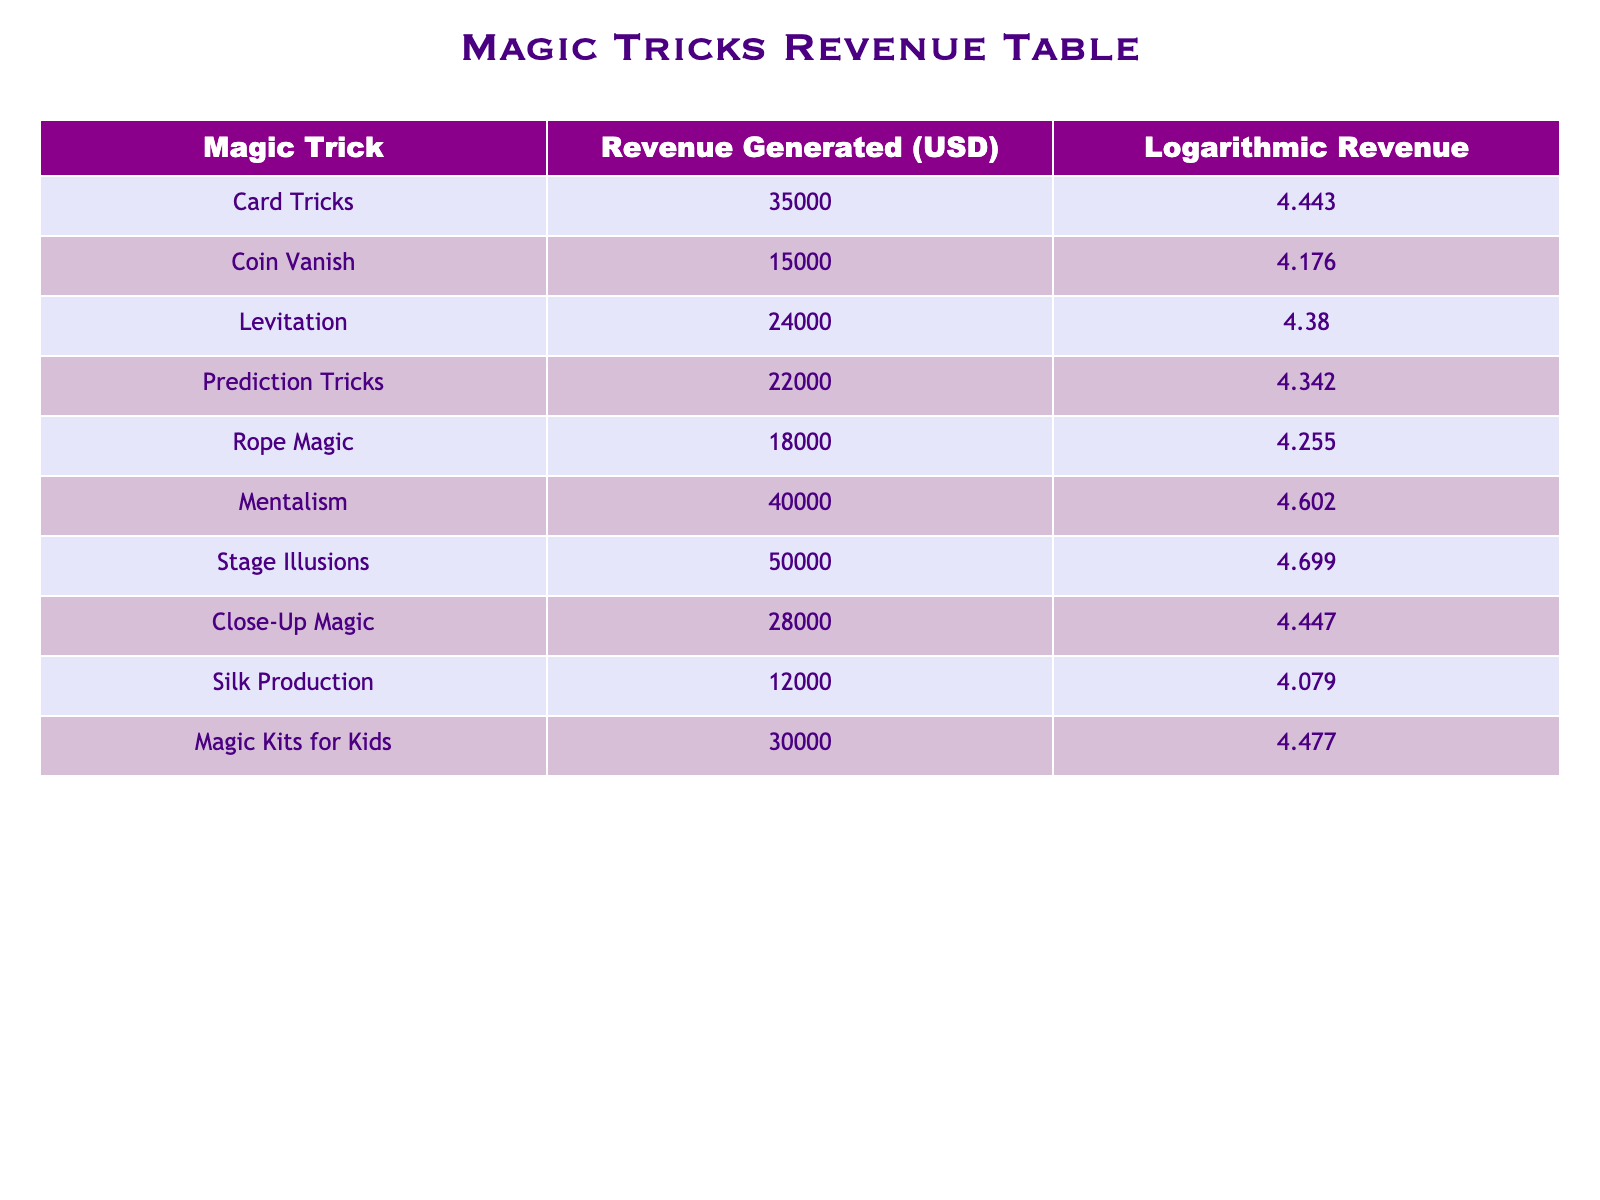What is the revenue generated from Stage Illusions? The table specifies the revenue values, and Stage Illusions are listed with a revenue of 50000 USD.
Answer: 50000 USD Which magic trick generated the lowest revenue? Reviewing the revenue figures, Silk Production shows the lowest revenue at 12000 USD.
Answer: Silk Production What is the average revenue of all listed magic tricks? To find the average, sum all revenue values: 35000 + 15000 + 24000 + 22000 + 18000 + 40000 + 50000 + 28000 + 12000 + 30000 = 225000 USD. There are 10 tricks, thus the average is 225000/10 = 22500 USD.
Answer: 22500 USD Is the revenue from Mentalism greater than that from Rope Magic? Mentalism has a revenue of 40000 USD while Rope Magic has 18000 USD. Comparing these values shows that Mentalism's revenue is indeed greater.
Answer: Yes What is the difference in revenue between the highest and lowest earning tricks? The highest earning trick is Stage Illusions at 50000 USD, while the lowest is Silk Production at 12000 USD. The difference is calculated as 50000 - 12000 = 38000 USD.
Answer: 38000 USD How many tricks generated more than 25000 USD? The tricks with revenues greater than 25000 USD are Card Tricks, Mentalism, Stage Illusions, and Magic Kits for Kids. Counting these, there are 4 tricks that meet the criteria.
Answer: 4 tricks What is the sum of the logarithmic revenues for Card Tricks and Coin Vanish? The logarithmic revenue for Card Tricks is 4.443 and for Coin Vanish it is 4.176. Adding these values gives 4.443 + 4.176 = 8.619.
Answer: 8.619 Which magic tricks have logarithmic revenue less than 4.300? Referencing the logarithmic values provided, Coin Vanish (4.176), Silk Production (4.079) are below 4.300. Collectively, there are 2 tricks fitting this criterion.
Answer: 2 tricks If you combine the revenues of Levitation and Close-Up Magic, what is the total? The revenues for Levitation is 24000 USD and Close-Up Magic is 28000 USD. Their combined revenue is 24000 + 28000 = 52000 USD.
Answer: 52000 USD 